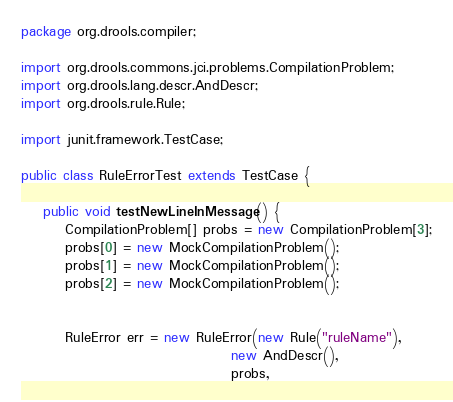<code> <loc_0><loc_0><loc_500><loc_500><_Java_>package org.drools.compiler;

import org.drools.commons.jci.problems.CompilationProblem;
import org.drools.lang.descr.AndDescr;
import org.drools.rule.Rule;

import junit.framework.TestCase;

public class RuleErrorTest extends TestCase {

    public void testNewLineInMessage() {
        CompilationProblem[] probs = new CompilationProblem[3];
        probs[0] = new MockCompilationProblem();
        probs[1] = new MockCompilationProblem();
        probs[2] = new MockCompilationProblem();

        
        RuleError err = new RuleError(new Rule("ruleName"), 
                                      new AndDescr(), 
                                      probs, </code> 